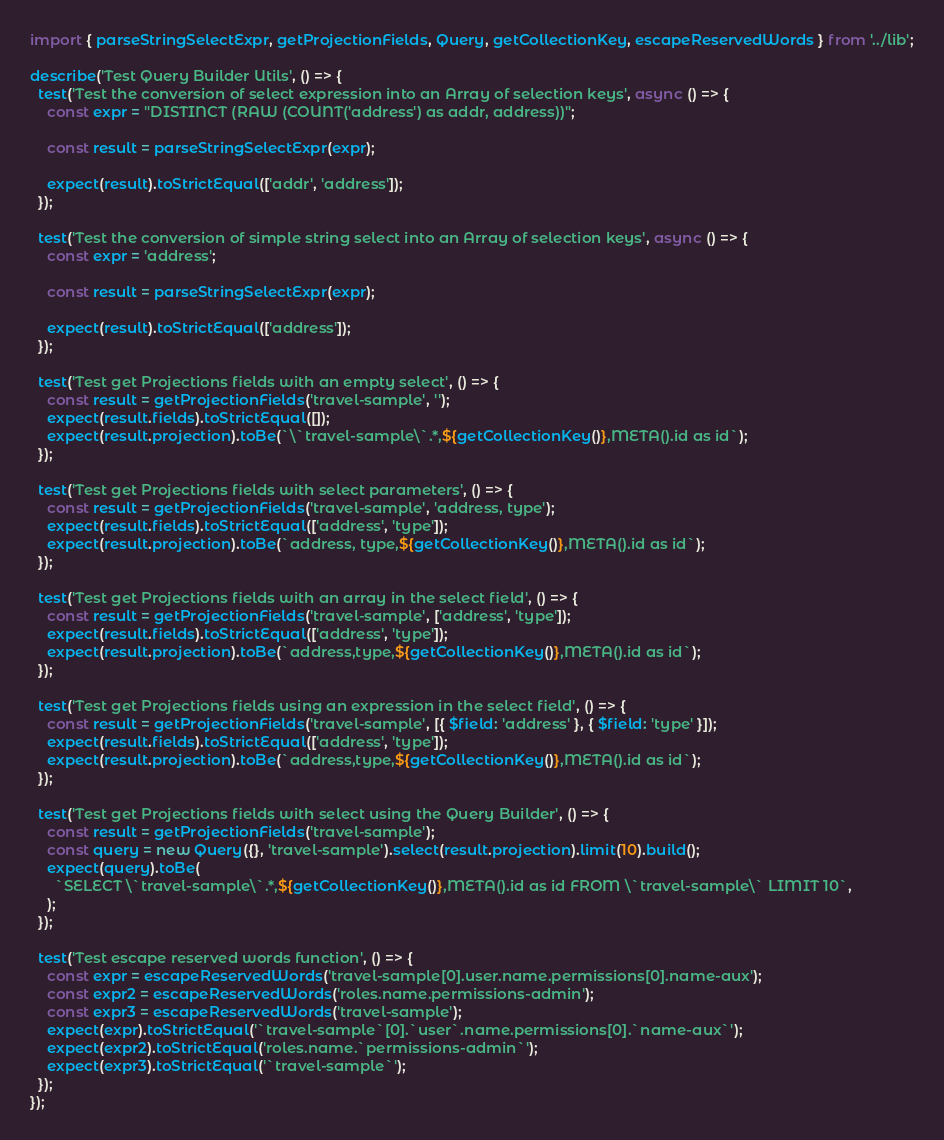<code> <loc_0><loc_0><loc_500><loc_500><_TypeScript_>import { parseStringSelectExpr, getProjectionFields, Query, getCollectionKey, escapeReservedWords } from '../lib';

describe('Test Query Builder Utils', () => {
  test('Test the conversion of select expression into an Array of selection keys', async () => {
    const expr = "DISTINCT (RAW (COUNT('address') as addr, address))";

    const result = parseStringSelectExpr(expr);

    expect(result).toStrictEqual(['addr', 'address']);
  });

  test('Test the conversion of simple string select into an Array of selection keys', async () => {
    const expr = 'address';

    const result = parseStringSelectExpr(expr);

    expect(result).toStrictEqual(['address']);
  });

  test('Test get Projections fields with an empty select', () => {
    const result = getProjectionFields('travel-sample', '');
    expect(result.fields).toStrictEqual([]);
    expect(result.projection).toBe(`\`travel-sample\`.*,${getCollectionKey()},META().id as id`);
  });

  test('Test get Projections fields with select parameters', () => {
    const result = getProjectionFields('travel-sample', 'address, type');
    expect(result.fields).toStrictEqual(['address', 'type']);
    expect(result.projection).toBe(`address, type,${getCollectionKey()},META().id as id`);
  });

  test('Test get Projections fields with an array in the select field', () => {
    const result = getProjectionFields('travel-sample', ['address', 'type']);
    expect(result.fields).toStrictEqual(['address', 'type']);
    expect(result.projection).toBe(`address,type,${getCollectionKey()},META().id as id`);
  });

  test('Test get Projections fields using an expression in the select field', () => {
    const result = getProjectionFields('travel-sample', [{ $field: 'address' }, { $field: 'type' }]);
    expect(result.fields).toStrictEqual(['address', 'type']);
    expect(result.projection).toBe(`address,type,${getCollectionKey()},META().id as id`);
  });

  test('Test get Projections fields with select using the Query Builder', () => {
    const result = getProjectionFields('travel-sample');
    const query = new Query({}, 'travel-sample').select(result.projection).limit(10).build();
    expect(query).toBe(
      `SELECT \`travel-sample\`.*,${getCollectionKey()},META().id as id FROM \`travel-sample\` LIMIT 10`,
    );
  });

  test('Test escape reserved words function', () => {
    const expr = escapeReservedWords('travel-sample[0].user.name.permissions[0].name-aux');
    const expr2 = escapeReservedWords('roles.name.permissions-admin');
    const expr3 = escapeReservedWords('travel-sample');
    expect(expr).toStrictEqual('`travel-sample`[0].`user`.name.permissions[0].`name-aux`');
    expect(expr2).toStrictEqual('roles.name.`permissions-admin`');
    expect(expr3).toStrictEqual('`travel-sample`');
  });
});
</code> 